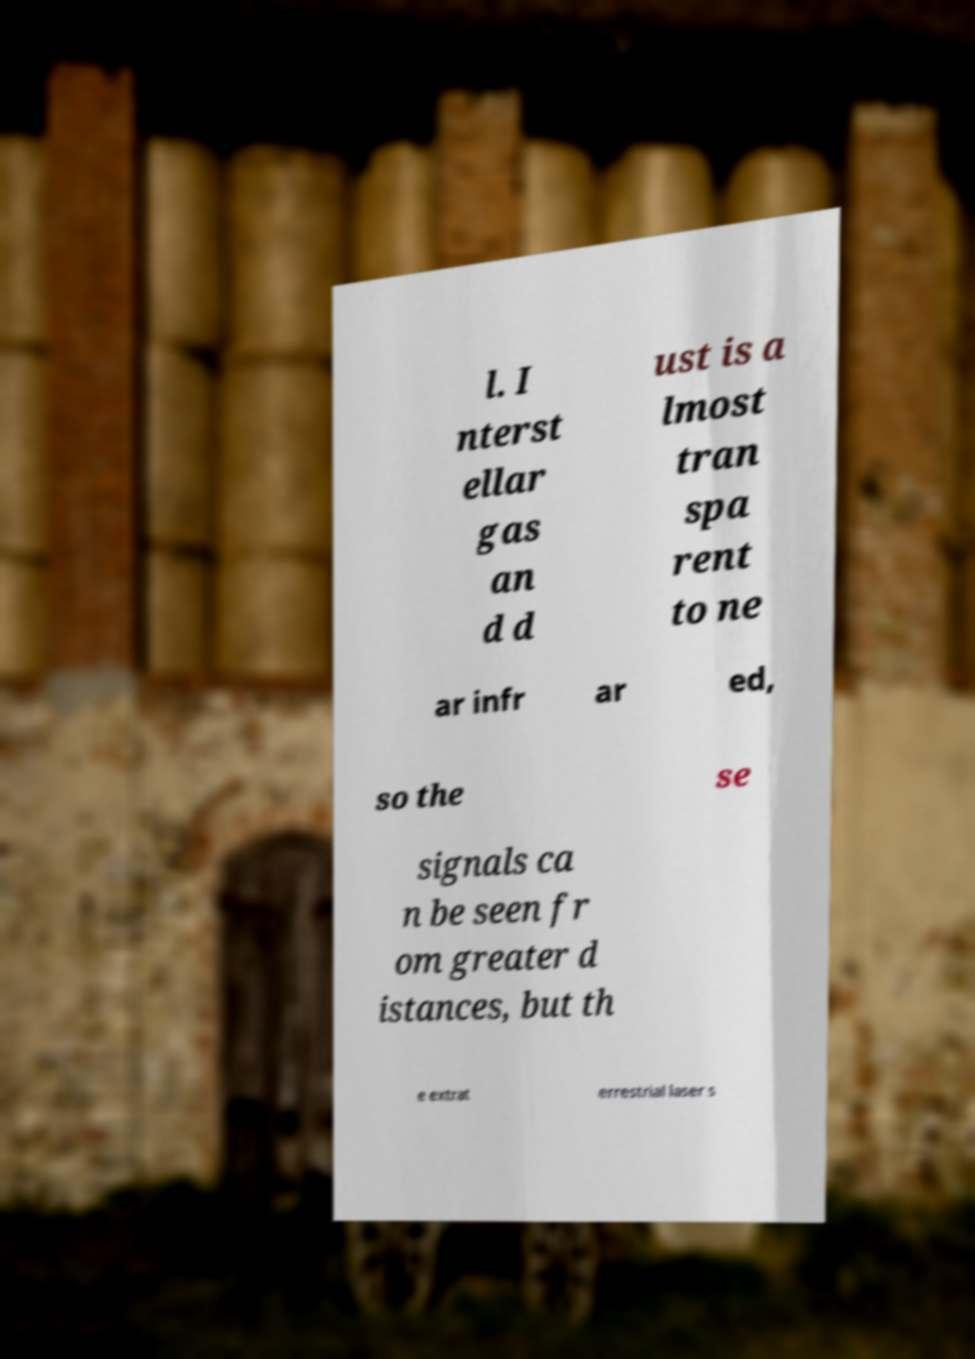Please identify and transcribe the text found in this image. l. I nterst ellar gas an d d ust is a lmost tran spa rent to ne ar infr ar ed, so the se signals ca n be seen fr om greater d istances, but th e extrat errestrial laser s 